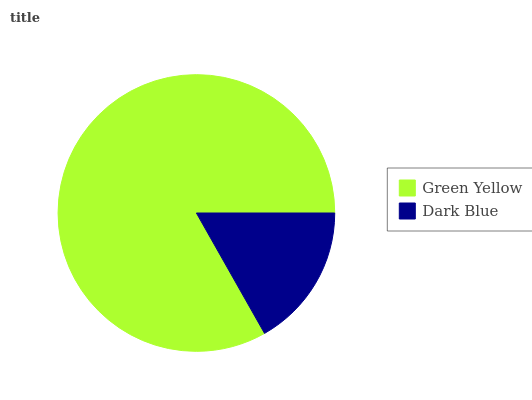Is Dark Blue the minimum?
Answer yes or no. Yes. Is Green Yellow the maximum?
Answer yes or no. Yes. Is Dark Blue the maximum?
Answer yes or no. No. Is Green Yellow greater than Dark Blue?
Answer yes or no. Yes. Is Dark Blue less than Green Yellow?
Answer yes or no. Yes. Is Dark Blue greater than Green Yellow?
Answer yes or no. No. Is Green Yellow less than Dark Blue?
Answer yes or no. No. Is Green Yellow the high median?
Answer yes or no. Yes. Is Dark Blue the low median?
Answer yes or no. Yes. Is Dark Blue the high median?
Answer yes or no. No. Is Green Yellow the low median?
Answer yes or no. No. 